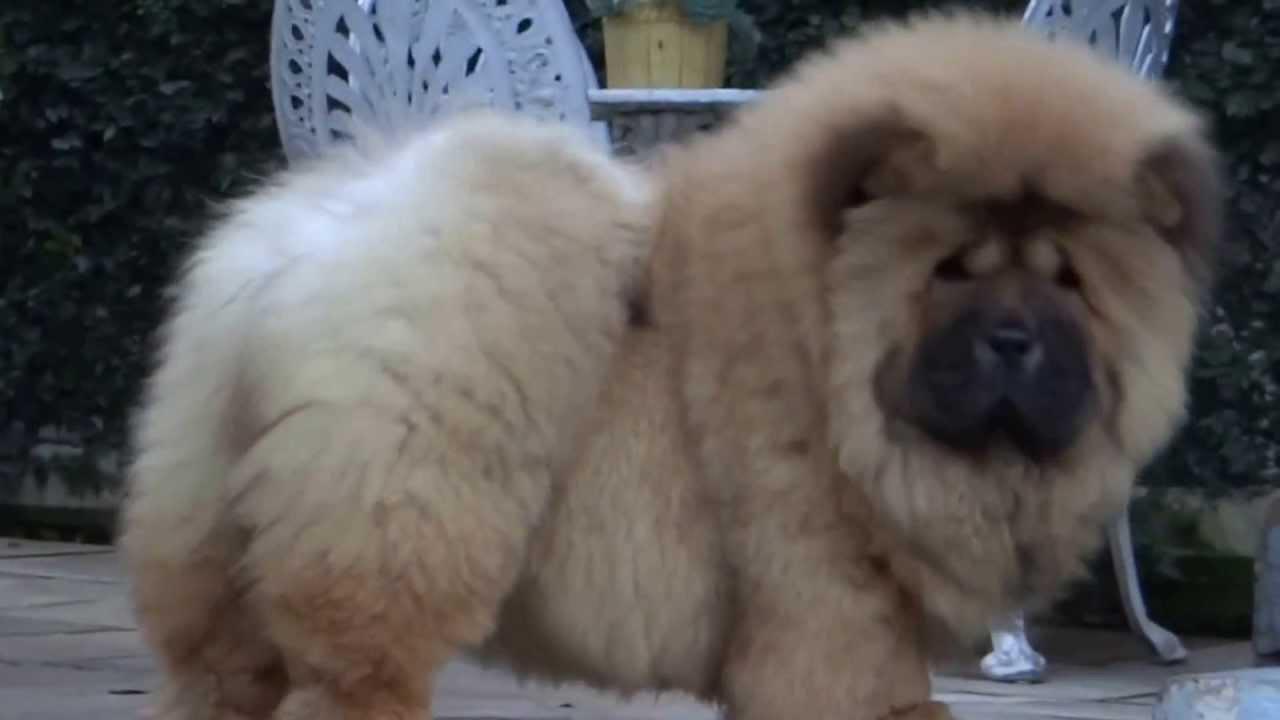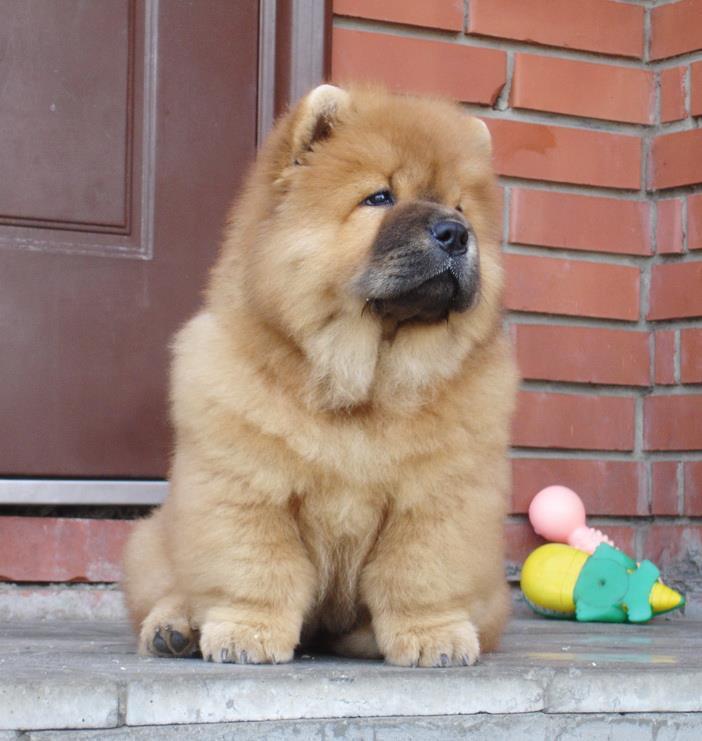The first image is the image on the left, the second image is the image on the right. Considering the images on both sides, is "One of the images shows a fluffy puppy running over grass toward the camera." valid? Answer yes or no. No. The first image is the image on the left, the second image is the image on the right. Analyze the images presented: Is the assertion "a puppy is leaping in the grass" valid? Answer yes or no. No. 